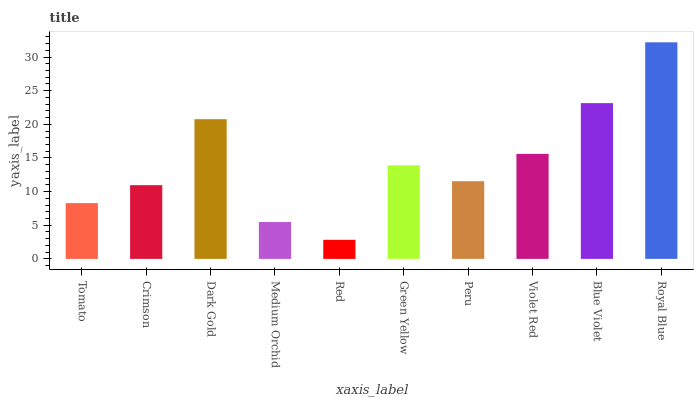Is Red the minimum?
Answer yes or no. Yes. Is Royal Blue the maximum?
Answer yes or no. Yes. Is Crimson the minimum?
Answer yes or no. No. Is Crimson the maximum?
Answer yes or no. No. Is Crimson greater than Tomato?
Answer yes or no. Yes. Is Tomato less than Crimson?
Answer yes or no. Yes. Is Tomato greater than Crimson?
Answer yes or no. No. Is Crimson less than Tomato?
Answer yes or no. No. Is Green Yellow the high median?
Answer yes or no. Yes. Is Peru the low median?
Answer yes or no. Yes. Is Crimson the high median?
Answer yes or no. No. Is Medium Orchid the low median?
Answer yes or no. No. 